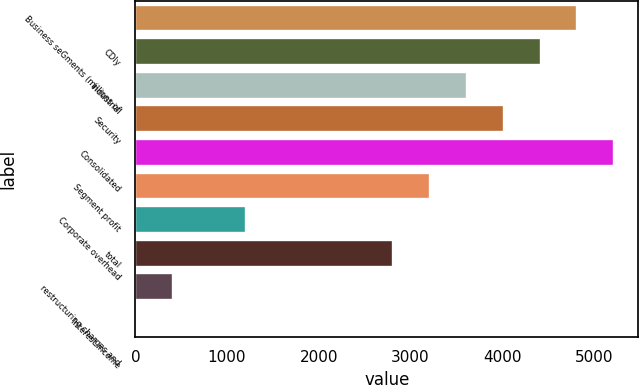<chart> <loc_0><loc_0><loc_500><loc_500><bar_chart><fcel>Business seGments (millions of<fcel>CDIy<fcel>Industrial<fcel>Security<fcel>Consolidated<fcel>Segment profit<fcel>Corporate overhead<fcel>total<fcel>restructuring charges and<fcel>Interest income<nl><fcel>4821.44<fcel>4420.02<fcel>3617.18<fcel>4018.6<fcel>5222.86<fcel>3215.76<fcel>1208.66<fcel>2814.34<fcel>405.82<fcel>4.4<nl></chart> 